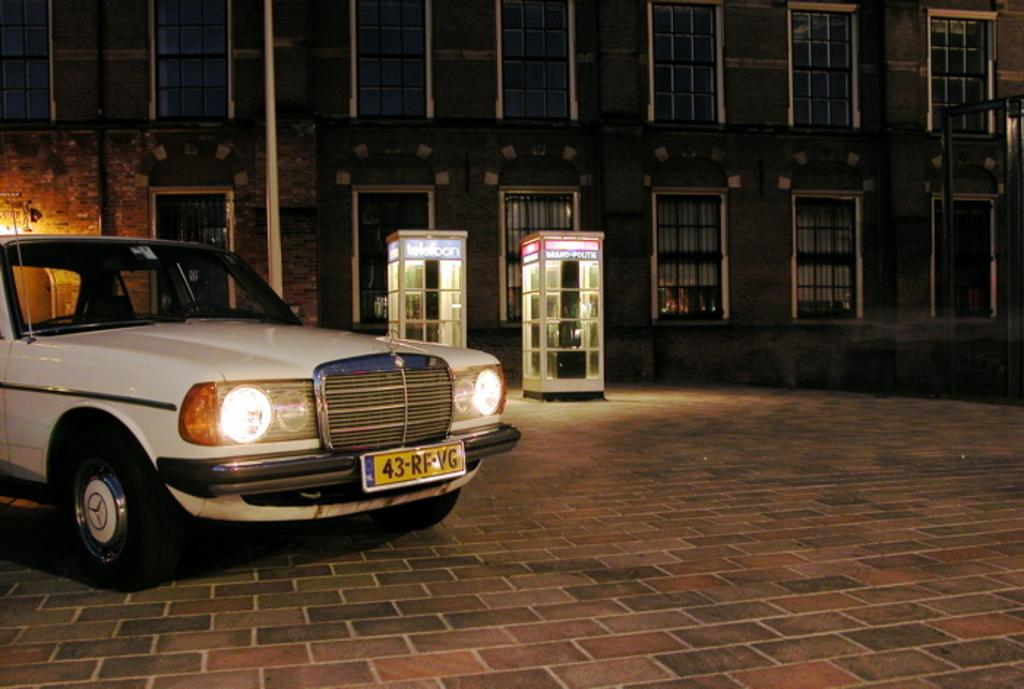What is the lighting condition in the image? The image was taken in the dark. What can be seen on the left side of the image? There is a car on the left side of the image. Where is the car located? The car is on the road. What structures are visible in the background of the image? There are two cabins and a building in the background of the image. What type of love is being expressed in the image? There is no indication of love or any emotional expression in the image; it primarily features a car on the road and structures in the background. 